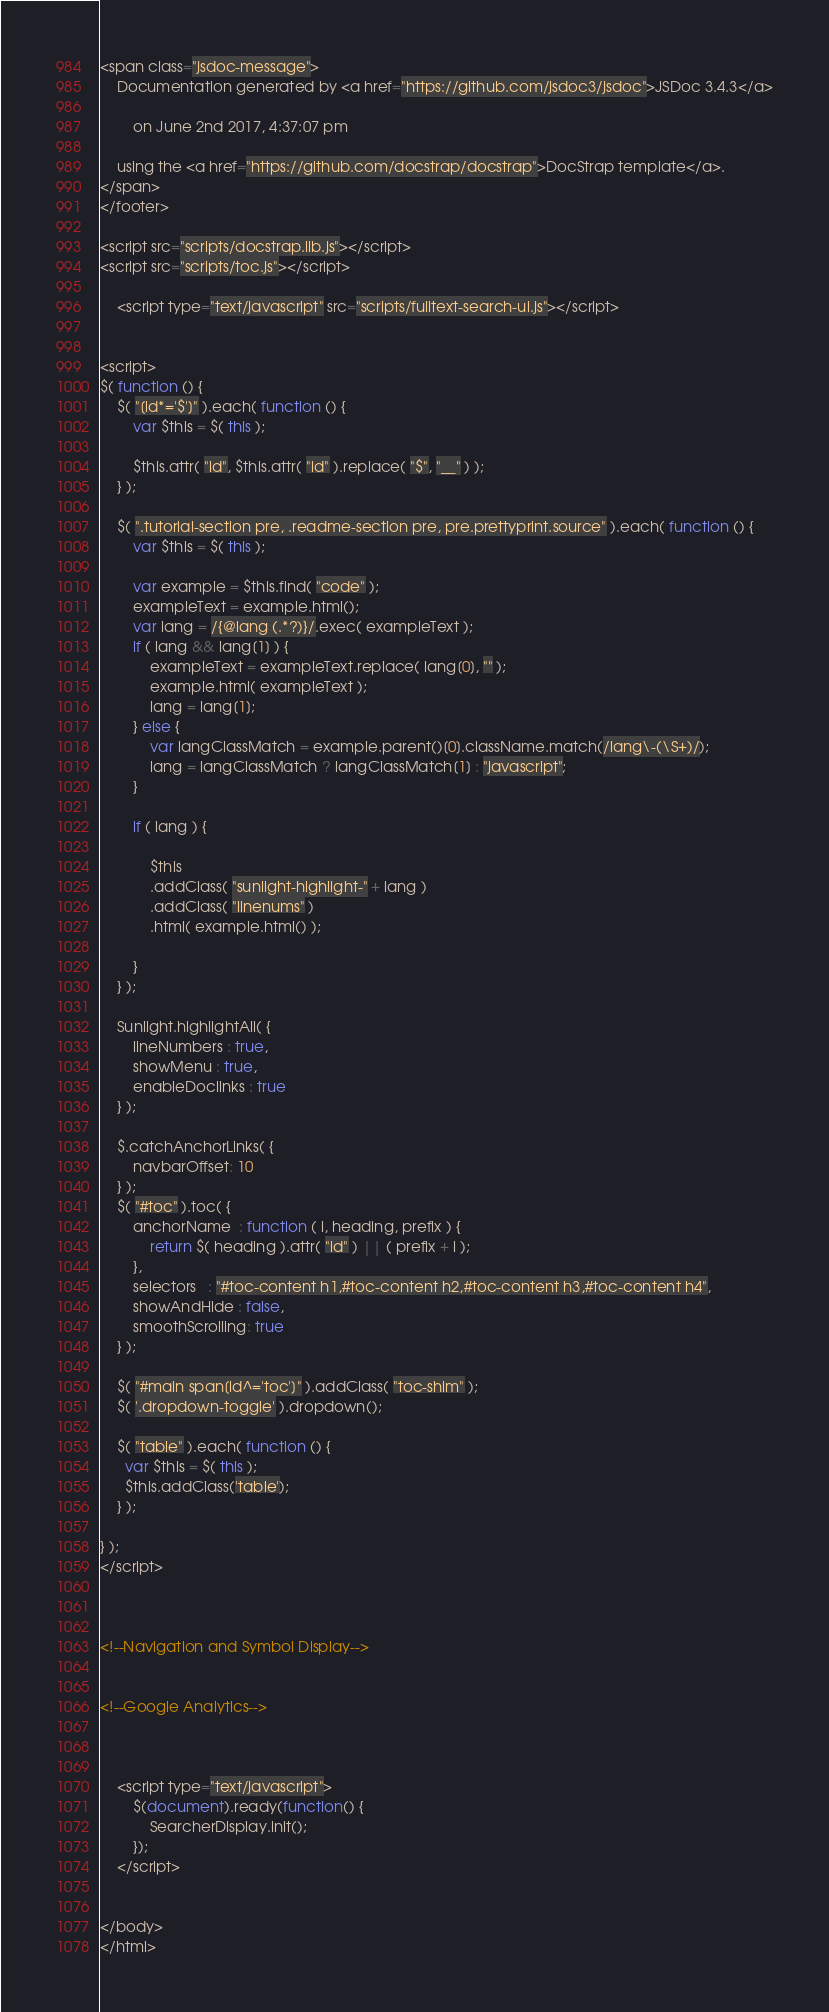<code> <loc_0><loc_0><loc_500><loc_500><_HTML_>
<span class="jsdoc-message">
	Documentation generated by <a href="https://github.com/jsdoc3/jsdoc">JSDoc 3.4.3</a>
	
		on June 2nd 2017, 4:37:07 pm
	
	using the <a href="https://github.com/docstrap/docstrap">DocStrap template</a>.
</span>
</footer>

<script src="scripts/docstrap.lib.js"></script>
<script src="scripts/toc.js"></script>

    <script type="text/javascript" src="scripts/fulltext-search-ui.js"></script>


<script>
$( function () {
	$( "[id*='$']" ).each( function () {
		var $this = $( this );

		$this.attr( "id", $this.attr( "id" ).replace( "$", "__" ) );
	} );

	$( ".tutorial-section pre, .readme-section pre, pre.prettyprint.source" ).each( function () {
		var $this = $( this );

		var example = $this.find( "code" );
		exampleText = example.html();
		var lang = /{@lang (.*?)}/.exec( exampleText );
		if ( lang && lang[1] ) {
			exampleText = exampleText.replace( lang[0], "" );
			example.html( exampleText );
			lang = lang[1];
		} else {
			var langClassMatch = example.parent()[0].className.match(/lang\-(\S+)/);
			lang = langClassMatch ? langClassMatch[1] : "javascript";
		}

		if ( lang ) {

			$this
			.addClass( "sunlight-highlight-" + lang )
			.addClass( "linenums" )
			.html( example.html() );

		}
	} );

	Sunlight.highlightAll( {
		lineNumbers : true,
		showMenu : true,
		enableDoclinks : true
	} );

	$.catchAnchorLinks( {
        navbarOffset: 10
	} );
	$( "#toc" ).toc( {
		anchorName  : function ( i, heading, prefix ) {
			return $( heading ).attr( "id" ) || ( prefix + i );
		},
		selectors   : "#toc-content h1,#toc-content h2,#toc-content h3,#toc-content h4",
		showAndHide : false,
		smoothScrolling: true
	} );

	$( "#main span[id^='toc']" ).addClass( "toc-shim" );
	$( '.dropdown-toggle' ).dropdown();

    $( "table" ).each( function () {
      var $this = $( this );
      $this.addClass('table');
    } );

} );
</script>



<!--Navigation and Symbol Display-->


<!--Google Analytics-->



    <script type="text/javascript">
        $(document).ready(function() {
            SearcherDisplay.init();
        });
    </script>


</body>
</html></code> 